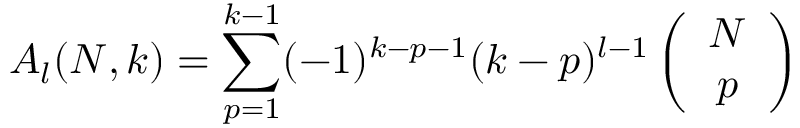<formula> <loc_0><loc_0><loc_500><loc_500>A _ { l } ( N , k ) = \sum _ { p = 1 } ^ { k - 1 } ( - 1 ) ^ { k - p - 1 } ( k - p ) ^ { l - 1 } \left ( \begin{array} { c } { N } \\ { p } \end{array} \right )</formula> 